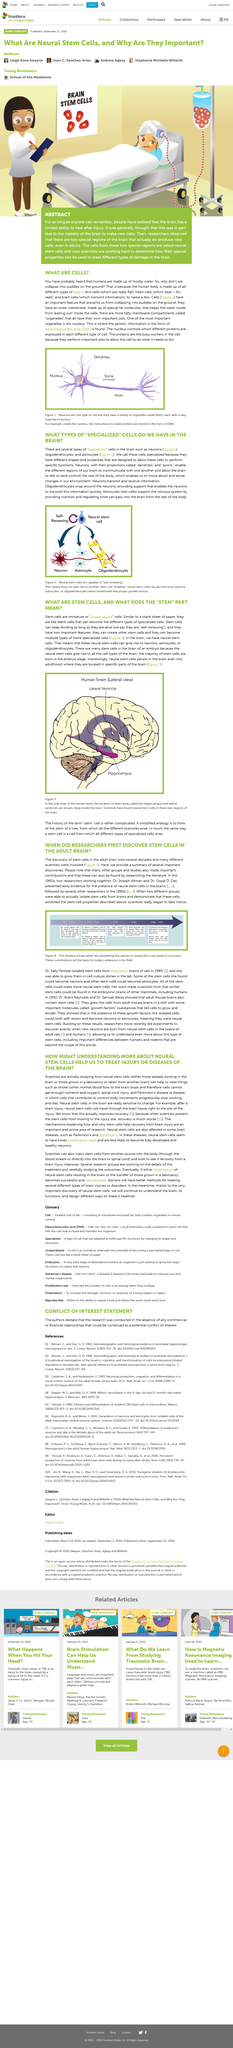Specify some key components in this picture. The cells are referred to as specialized because they have distinct shapes and properties that are specifically designed to enable them to perform specific functions. In the 1960s, Dr. Joseph Altman and Dr. Gopal D. Das presented early evidence for the presence of neural stem cells in the brains, marking a significant milestone in the field of neuroscience. The majority of brain cells are born in the embryonic stage of development. Yes, neurons have projections known as dendrites and axons. Stem cells possess two crucial characteristics. Firstly, they have the remarkable ability to generate additional stem cells of the same type, and secondly, they are capable of differentiating into a variety of specialized cells with more specific functions. These unique features of stem cells hold great promise for the advancement of medical treatments and therapies. 